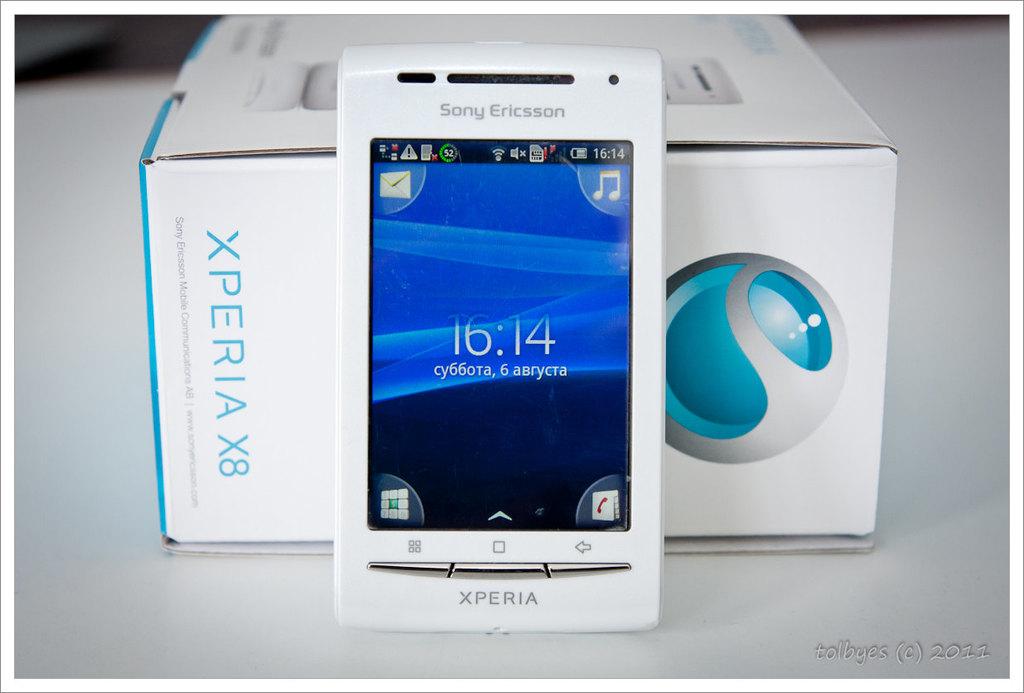Which company made the cell phone?
Offer a very short reply. Sony ericsson. 